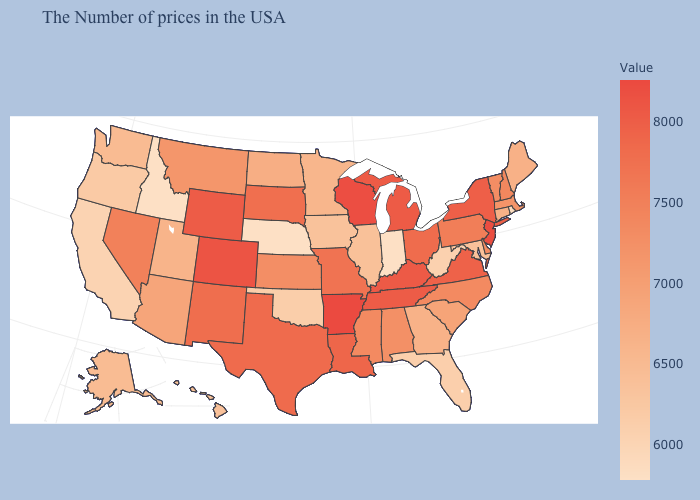Among the states that border New Mexico , which have the highest value?
Write a very short answer. Colorado. Which states have the lowest value in the South?
Write a very short answer. West Virginia. Among the states that border Missouri , does Oklahoma have the lowest value?
Concise answer only. No. Which states hav the highest value in the West?
Quick response, please. Colorado. Does Georgia have a lower value than Massachusetts?
Quick response, please. Yes. Does Alabama have the highest value in the South?
Keep it brief. No. 